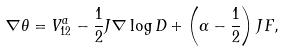<formula> <loc_0><loc_0><loc_500><loc_500>\nabla \theta = V _ { 1 2 } ^ { a } - \frac { 1 } { 2 } J \nabla \log D + \left ( \alpha - \frac { 1 } { 2 } \right ) J F ,</formula> 